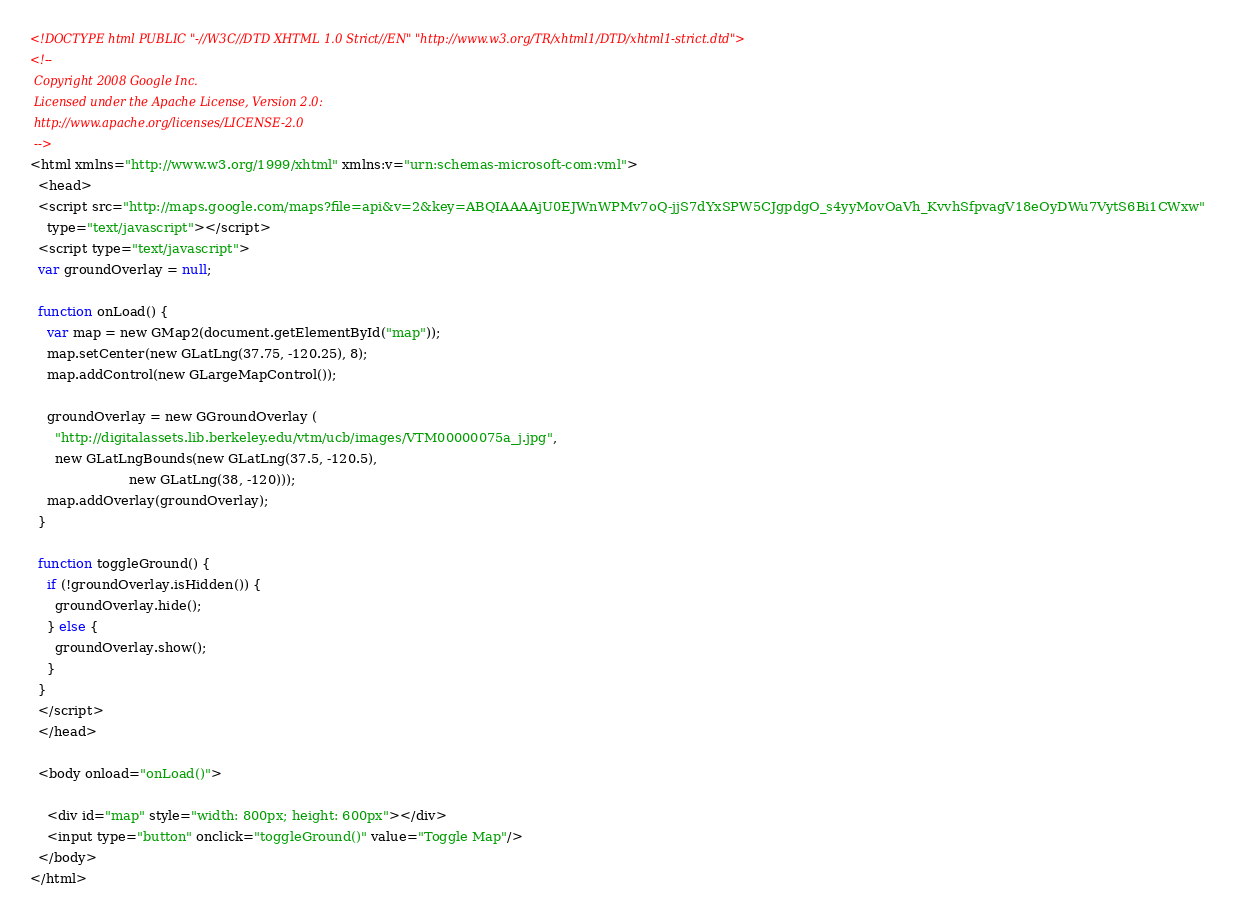Convert code to text. <code><loc_0><loc_0><loc_500><loc_500><_HTML_><!DOCTYPE html PUBLIC "-//W3C//DTD XHTML 1.0 Strict//EN" "http://www.w3.org/TR/xhtml1/DTD/xhtml1-strict.dtd">
<!--
 Copyright 2008 Google Inc. 
 Licensed under the Apache License, Version 2.0: 
 http://www.apache.org/licenses/LICENSE-2.0 
 -->
<html xmlns="http://www.w3.org/1999/xhtml" xmlns:v="urn:schemas-microsoft-com:vml">
  <head>
  <script src="http://maps.google.com/maps?file=api&v=2&key=ABQIAAAAjU0EJWnWPMv7oQ-jjS7dYxSPW5CJgpdgO_s4yyMovOaVh_KvvhSfpvagV18eOyDWu7VytS6Bi1CWxw" 
    type="text/javascript"></script>
  <script type="text/javascript">
  var groundOverlay = null;

  function onLoad() {
    var map = new GMap2(document.getElementById("map"));
    map.setCenter(new GLatLng(37.75, -120.25), 8);
    map.addControl(new GLargeMapControl());

    groundOverlay = new GGroundOverlay (
      "http://digitalassets.lib.berkeley.edu/vtm/ucb/images/VTM00000075a_j.jpg",
      new GLatLngBounds(new GLatLng(37.5, -120.5),
                        new GLatLng(38, -120)));
    map.addOverlay(groundOverlay);
  }
  
  function toggleGround() {
    if (!groundOverlay.isHidden()) {
      groundOverlay.hide();
    } else {
      groundOverlay.show();
    } 
  }
  </script>
  </head>

  <body onload="onLoad()">

    <div id="map" style="width: 800px; height: 600px"></div>
    <input type="button" onclick="toggleGround()" value="Toggle Map"/>
  </body>
</html>

</code> 